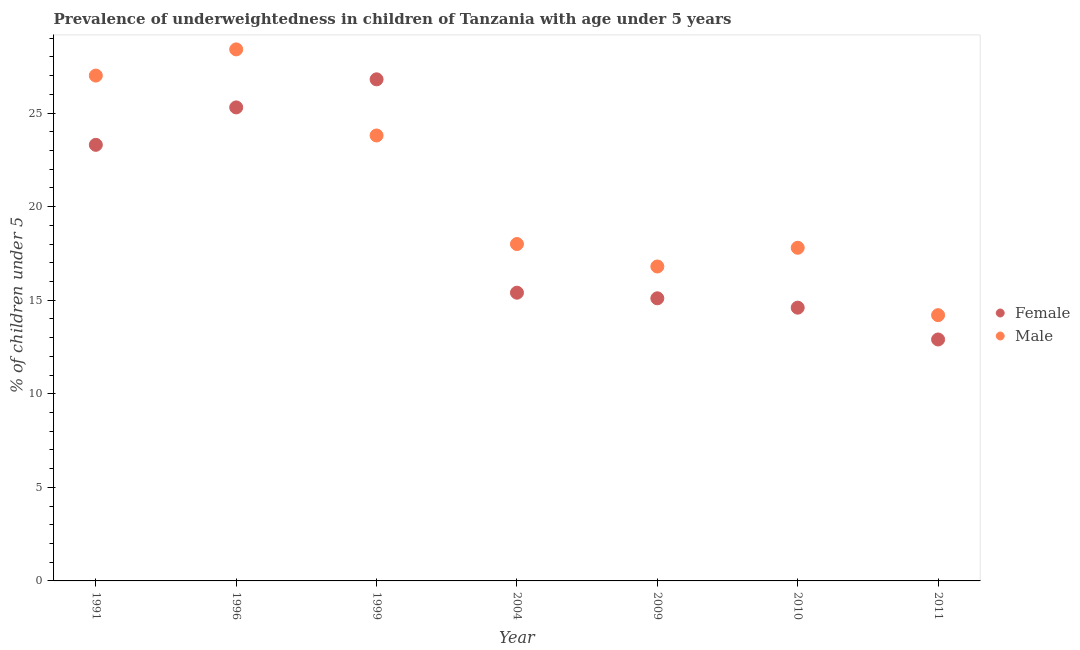How many different coloured dotlines are there?
Provide a short and direct response. 2. Is the number of dotlines equal to the number of legend labels?
Make the answer very short. Yes. What is the percentage of underweighted female children in 1991?
Make the answer very short. 23.3. Across all years, what is the maximum percentage of underweighted female children?
Provide a short and direct response. 26.8. Across all years, what is the minimum percentage of underweighted male children?
Give a very brief answer. 14.2. In which year was the percentage of underweighted female children minimum?
Offer a terse response. 2011. What is the total percentage of underweighted male children in the graph?
Provide a succinct answer. 146. What is the difference between the percentage of underweighted male children in 1999 and that in 2004?
Provide a short and direct response. 5.8. What is the difference between the percentage of underweighted female children in 1999 and the percentage of underweighted male children in 2004?
Provide a short and direct response. 8.8. What is the average percentage of underweighted female children per year?
Keep it short and to the point. 19.06. In the year 2009, what is the difference between the percentage of underweighted female children and percentage of underweighted male children?
Your answer should be very brief. -1.7. In how many years, is the percentage of underweighted female children greater than 5 %?
Provide a short and direct response. 7. What is the ratio of the percentage of underweighted male children in 1996 to that in 2010?
Provide a short and direct response. 1.6. Is the percentage of underweighted male children in 1996 less than that in 2011?
Provide a succinct answer. No. Is the difference between the percentage of underweighted female children in 1991 and 2004 greater than the difference between the percentage of underweighted male children in 1991 and 2004?
Give a very brief answer. No. What is the difference between the highest and the second highest percentage of underweighted male children?
Ensure brevity in your answer.  1.4. What is the difference between the highest and the lowest percentage of underweighted male children?
Keep it short and to the point. 14.2. Is the sum of the percentage of underweighted female children in 1991 and 2010 greater than the maximum percentage of underweighted male children across all years?
Offer a very short reply. Yes. Is the percentage of underweighted male children strictly greater than the percentage of underweighted female children over the years?
Your answer should be compact. No. Does the graph contain grids?
Provide a succinct answer. No. How are the legend labels stacked?
Offer a very short reply. Vertical. What is the title of the graph?
Make the answer very short. Prevalence of underweightedness in children of Tanzania with age under 5 years. What is the label or title of the X-axis?
Offer a very short reply. Year. What is the label or title of the Y-axis?
Make the answer very short.  % of children under 5. What is the  % of children under 5 of Female in 1991?
Give a very brief answer. 23.3. What is the  % of children under 5 in Male in 1991?
Provide a succinct answer. 27. What is the  % of children under 5 in Female in 1996?
Your answer should be very brief. 25.3. What is the  % of children under 5 in Male in 1996?
Ensure brevity in your answer.  28.4. What is the  % of children under 5 in Female in 1999?
Keep it short and to the point. 26.8. What is the  % of children under 5 of Male in 1999?
Provide a succinct answer. 23.8. What is the  % of children under 5 of Female in 2004?
Make the answer very short. 15.4. What is the  % of children under 5 of Male in 2004?
Your answer should be compact. 18. What is the  % of children under 5 in Female in 2009?
Make the answer very short. 15.1. What is the  % of children under 5 in Male in 2009?
Provide a short and direct response. 16.8. What is the  % of children under 5 of Female in 2010?
Make the answer very short. 14.6. What is the  % of children under 5 of Male in 2010?
Provide a short and direct response. 17.8. What is the  % of children under 5 of Female in 2011?
Your answer should be compact. 12.9. What is the  % of children under 5 in Male in 2011?
Provide a short and direct response. 14.2. Across all years, what is the maximum  % of children under 5 in Female?
Your answer should be very brief. 26.8. Across all years, what is the maximum  % of children under 5 in Male?
Offer a very short reply. 28.4. Across all years, what is the minimum  % of children under 5 in Female?
Offer a very short reply. 12.9. Across all years, what is the minimum  % of children under 5 of Male?
Provide a short and direct response. 14.2. What is the total  % of children under 5 in Female in the graph?
Ensure brevity in your answer.  133.4. What is the total  % of children under 5 in Male in the graph?
Provide a short and direct response. 146. What is the difference between the  % of children under 5 of Female in 1991 and that in 1996?
Your response must be concise. -2. What is the difference between the  % of children under 5 of Male in 1991 and that in 1999?
Offer a very short reply. 3.2. What is the difference between the  % of children under 5 of Male in 1991 and that in 2004?
Ensure brevity in your answer.  9. What is the difference between the  % of children under 5 in Female in 1991 and that in 2009?
Keep it short and to the point. 8.2. What is the difference between the  % of children under 5 in Male in 1991 and that in 2009?
Your response must be concise. 10.2. What is the difference between the  % of children under 5 in Female in 1996 and that in 1999?
Provide a succinct answer. -1.5. What is the difference between the  % of children under 5 of Male in 1996 and that in 2004?
Make the answer very short. 10.4. What is the difference between the  % of children under 5 in Female in 1996 and that in 2009?
Keep it short and to the point. 10.2. What is the difference between the  % of children under 5 of Male in 1996 and that in 2010?
Your answer should be very brief. 10.6. What is the difference between the  % of children under 5 in Female in 1996 and that in 2011?
Give a very brief answer. 12.4. What is the difference between the  % of children under 5 of Male in 1996 and that in 2011?
Your answer should be compact. 14.2. What is the difference between the  % of children under 5 of Female in 1999 and that in 2004?
Provide a short and direct response. 11.4. What is the difference between the  % of children under 5 of Male in 1999 and that in 2004?
Offer a very short reply. 5.8. What is the difference between the  % of children under 5 of Female in 1999 and that in 2011?
Your response must be concise. 13.9. What is the difference between the  % of children under 5 of Female in 2004 and that in 2009?
Offer a terse response. 0.3. What is the difference between the  % of children under 5 in Male in 2004 and that in 2009?
Ensure brevity in your answer.  1.2. What is the difference between the  % of children under 5 in Male in 2004 and that in 2011?
Provide a succinct answer. 3.8. What is the difference between the  % of children under 5 of Female in 2009 and that in 2011?
Keep it short and to the point. 2.2. What is the difference between the  % of children under 5 of Female in 2010 and that in 2011?
Keep it short and to the point. 1.7. What is the difference between the  % of children under 5 of Female in 1991 and the  % of children under 5 of Male in 1996?
Offer a terse response. -5.1. What is the difference between the  % of children under 5 of Female in 1991 and the  % of children under 5 of Male in 1999?
Give a very brief answer. -0.5. What is the difference between the  % of children under 5 in Female in 1991 and the  % of children under 5 in Male in 2009?
Ensure brevity in your answer.  6.5. What is the difference between the  % of children under 5 of Female in 1991 and the  % of children under 5 of Male in 2010?
Give a very brief answer. 5.5. What is the difference between the  % of children under 5 in Female in 1991 and the  % of children under 5 in Male in 2011?
Make the answer very short. 9.1. What is the difference between the  % of children under 5 of Female in 1996 and the  % of children under 5 of Male in 1999?
Your response must be concise. 1.5. What is the difference between the  % of children under 5 of Female in 1996 and the  % of children under 5 of Male in 2010?
Keep it short and to the point. 7.5. What is the difference between the  % of children under 5 in Female in 1999 and the  % of children under 5 in Male in 2004?
Offer a terse response. 8.8. What is the difference between the  % of children under 5 of Female in 1999 and the  % of children under 5 of Male in 2009?
Give a very brief answer. 10. What is the difference between the  % of children under 5 of Female in 1999 and the  % of children under 5 of Male in 2010?
Your answer should be very brief. 9. What is the difference between the  % of children under 5 of Female in 2009 and the  % of children under 5 of Male in 2010?
Make the answer very short. -2.7. What is the average  % of children under 5 in Female per year?
Make the answer very short. 19.06. What is the average  % of children under 5 of Male per year?
Your response must be concise. 20.86. In the year 1996, what is the difference between the  % of children under 5 of Female and  % of children under 5 of Male?
Offer a very short reply. -3.1. In the year 2009, what is the difference between the  % of children under 5 in Female and  % of children under 5 in Male?
Provide a succinct answer. -1.7. What is the ratio of the  % of children under 5 in Female in 1991 to that in 1996?
Ensure brevity in your answer.  0.92. What is the ratio of the  % of children under 5 of Male in 1991 to that in 1996?
Your answer should be very brief. 0.95. What is the ratio of the  % of children under 5 in Female in 1991 to that in 1999?
Provide a short and direct response. 0.87. What is the ratio of the  % of children under 5 in Male in 1991 to that in 1999?
Provide a succinct answer. 1.13. What is the ratio of the  % of children under 5 of Female in 1991 to that in 2004?
Keep it short and to the point. 1.51. What is the ratio of the  % of children under 5 in Male in 1991 to that in 2004?
Offer a terse response. 1.5. What is the ratio of the  % of children under 5 of Female in 1991 to that in 2009?
Offer a very short reply. 1.54. What is the ratio of the  % of children under 5 in Male in 1991 to that in 2009?
Ensure brevity in your answer.  1.61. What is the ratio of the  % of children under 5 in Female in 1991 to that in 2010?
Provide a succinct answer. 1.6. What is the ratio of the  % of children under 5 in Male in 1991 to that in 2010?
Give a very brief answer. 1.52. What is the ratio of the  % of children under 5 in Female in 1991 to that in 2011?
Give a very brief answer. 1.81. What is the ratio of the  % of children under 5 in Male in 1991 to that in 2011?
Provide a short and direct response. 1.9. What is the ratio of the  % of children under 5 of Female in 1996 to that in 1999?
Offer a terse response. 0.94. What is the ratio of the  % of children under 5 in Male in 1996 to that in 1999?
Offer a very short reply. 1.19. What is the ratio of the  % of children under 5 in Female in 1996 to that in 2004?
Keep it short and to the point. 1.64. What is the ratio of the  % of children under 5 in Male in 1996 to that in 2004?
Ensure brevity in your answer.  1.58. What is the ratio of the  % of children under 5 of Female in 1996 to that in 2009?
Make the answer very short. 1.68. What is the ratio of the  % of children under 5 of Male in 1996 to that in 2009?
Offer a terse response. 1.69. What is the ratio of the  % of children under 5 of Female in 1996 to that in 2010?
Your answer should be very brief. 1.73. What is the ratio of the  % of children under 5 in Male in 1996 to that in 2010?
Your answer should be very brief. 1.6. What is the ratio of the  % of children under 5 of Female in 1996 to that in 2011?
Give a very brief answer. 1.96. What is the ratio of the  % of children under 5 in Male in 1996 to that in 2011?
Offer a very short reply. 2. What is the ratio of the  % of children under 5 of Female in 1999 to that in 2004?
Offer a very short reply. 1.74. What is the ratio of the  % of children under 5 of Male in 1999 to that in 2004?
Provide a succinct answer. 1.32. What is the ratio of the  % of children under 5 in Female in 1999 to that in 2009?
Offer a very short reply. 1.77. What is the ratio of the  % of children under 5 of Male in 1999 to that in 2009?
Your answer should be very brief. 1.42. What is the ratio of the  % of children under 5 in Female in 1999 to that in 2010?
Ensure brevity in your answer.  1.84. What is the ratio of the  % of children under 5 in Male in 1999 to that in 2010?
Provide a short and direct response. 1.34. What is the ratio of the  % of children under 5 in Female in 1999 to that in 2011?
Offer a terse response. 2.08. What is the ratio of the  % of children under 5 of Male in 1999 to that in 2011?
Give a very brief answer. 1.68. What is the ratio of the  % of children under 5 of Female in 2004 to that in 2009?
Provide a succinct answer. 1.02. What is the ratio of the  % of children under 5 in Male in 2004 to that in 2009?
Provide a succinct answer. 1.07. What is the ratio of the  % of children under 5 of Female in 2004 to that in 2010?
Your answer should be very brief. 1.05. What is the ratio of the  % of children under 5 in Male in 2004 to that in 2010?
Offer a very short reply. 1.01. What is the ratio of the  % of children under 5 in Female in 2004 to that in 2011?
Offer a terse response. 1.19. What is the ratio of the  % of children under 5 of Male in 2004 to that in 2011?
Keep it short and to the point. 1.27. What is the ratio of the  % of children under 5 in Female in 2009 to that in 2010?
Provide a succinct answer. 1.03. What is the ratio of the  % of children under 5 of Male in 2009 to that in 2010?
Ensure brevity in your answer.  0.94. What is the ratio of the  % of children under 5 in Female in 2009 to that in 2011?
Your response must be concise. 1.17. What is the ratio of the  % of children under 5 of Male in 2009 to that in 2011?
Provide a succinct answer. 1.18. What is the ratio of the  % of children under 5 in Female in 2010 to that in 2011?
Provide a short and direct response. 1.13. What is the ratio of the  % of children under 5 in Male in 2010 to that in 2011?
Your answer should be compact. 1.25. What is the difference between the highest and the second highest  % of children under 5 of Male?
Ensure brevity in your answer.  1.4. What is the difference between the highest and the lowest  % of children under 5 of Male?
Your answer should be compact. 14.2. 